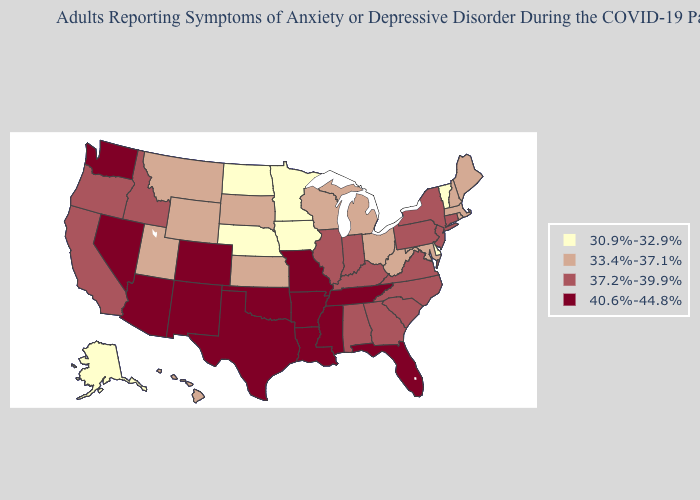Does Louisiana have the lowest value in the USA?
Be succinct. No. What is the value of Florida?
Short answer required. 40.6%-44.8%. Among the states that border Nevada , does Oregon have the lowest value?
Keep it brief. No. Does Massachusetts have the same value as New Mexico?
Answer briefly. No. Name the states that have a value in the range 33.4%-37.1%?
Write a very short answer. Hawaii, Kansas, Maine, Maryland, Massachusetts, Michigan, Montana, New Hampshire, Ohio, Rhode Island, South Dakota, Utah, West Virginia, Wisconsin, Wyoming. What is the value of Missouri?
Concise answer only. 40.6%-44.8%. What is the lowest value in states that border Arkansas?
Write a very short answer. 40.6%-44.8%. Name the states that have a value in the range 40.6%-44.8%?
Write a very short answer. Arizona, Arkansas, Colorado, Florida, Louisiana, Mississippi, Missouri, Nevada, New Mexico, Oklahoma, Tennessee, Texas, Washington. Does Utah have a higher value than Delaware?
Write a very short answer. Yes. What is the value of Arizona?
Keep it brief. 40.6%-44.8%. Which states have the lowest value in the USA?
Write a very short answer. Alaska, Delaware, Iowa, Minnesota, Nebraska, North Dakota, Vermont. Does Hawaii have the highest value in the USA?
Concise answer only. No. What is the value of Nevada?
Be succinct. 40.6%-44.8%. Among the states that border West Virginia , does Ohio have the lowest value?
Short answer required. Yes. Does Arizona have the highest value in the West?
Concise answer only. Yes. 